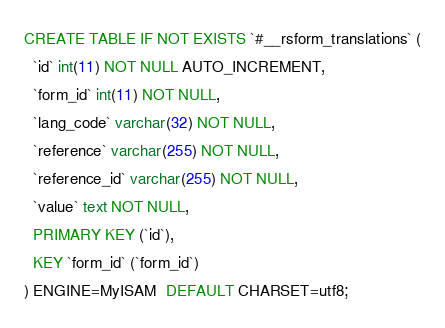<code> <loc_0><loc_0><loc_500><loc_500><_SQL_>CREATE TABLE IF NOT EXISTS `#__rsform_translations` (
  `id` int(11) NOT NULL AUTO_INCREMENT,
  `form_id` int(11) NOT NULL,
  `lang_code` varchar(32) NOT NULL,
  `reference` varchar(255) NOT NULL,
  `reference_id` varchar(255) NOT NULL,
  `value` text NOT NULL,
  PRIMARY KEY (`id`),
  KEY `form_id` (`form_id`)
) ENGINE=MyISAM  DEFAULT CHARSET=utf8;</code> 